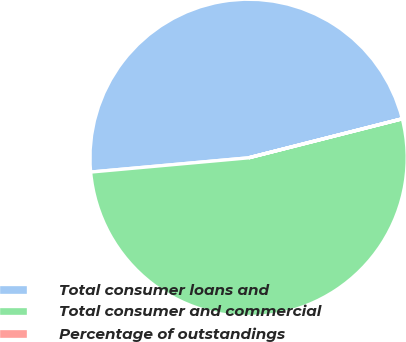<chart> <loc_0><loc_0><loc_500><loc_500><pie_chart><fcel>Total consumer loans and<fcel>Total consumer and commercial<fcel>Percentage of outstandings<nl><fcel>47.47%<fcel>52.53%<fcel>0.01%<nl></chart> 